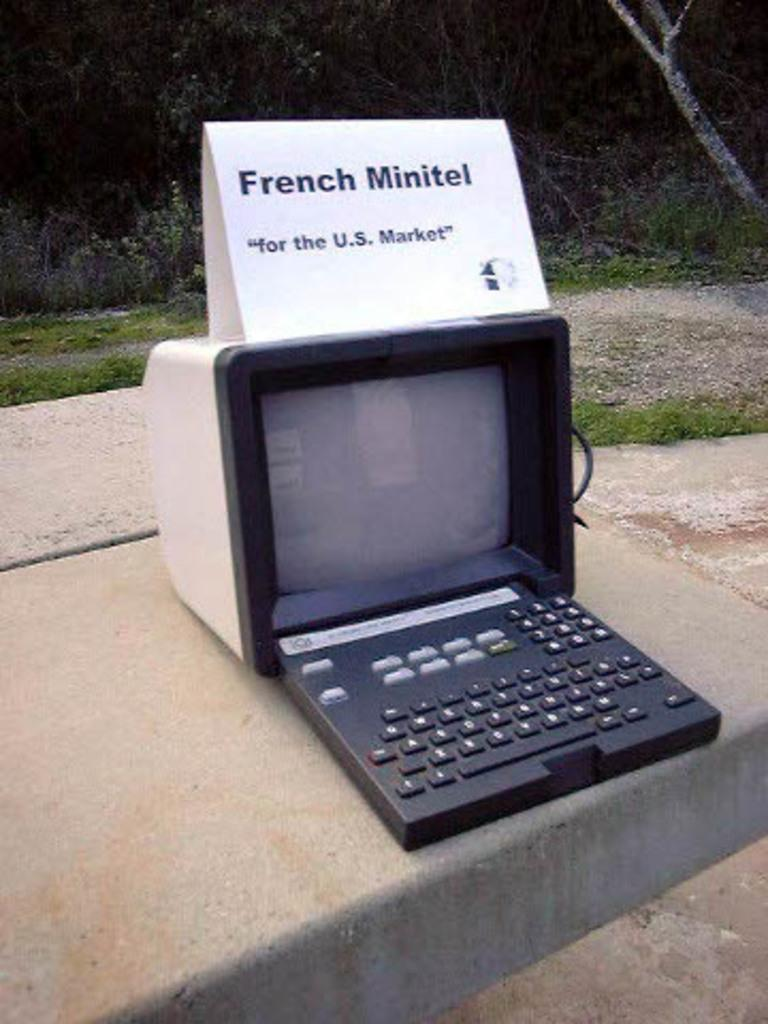<image>
Present a compact description of the photo's key features. a very old monitor with an attached keyboard that has a sign that reads french minitel on top of it. 